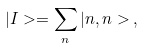Convert formula to latex. <formula><loc_0><loc_0><loc_500><loc_500>| I > = \sum _ { n } | n , n > \, ,</formula> 